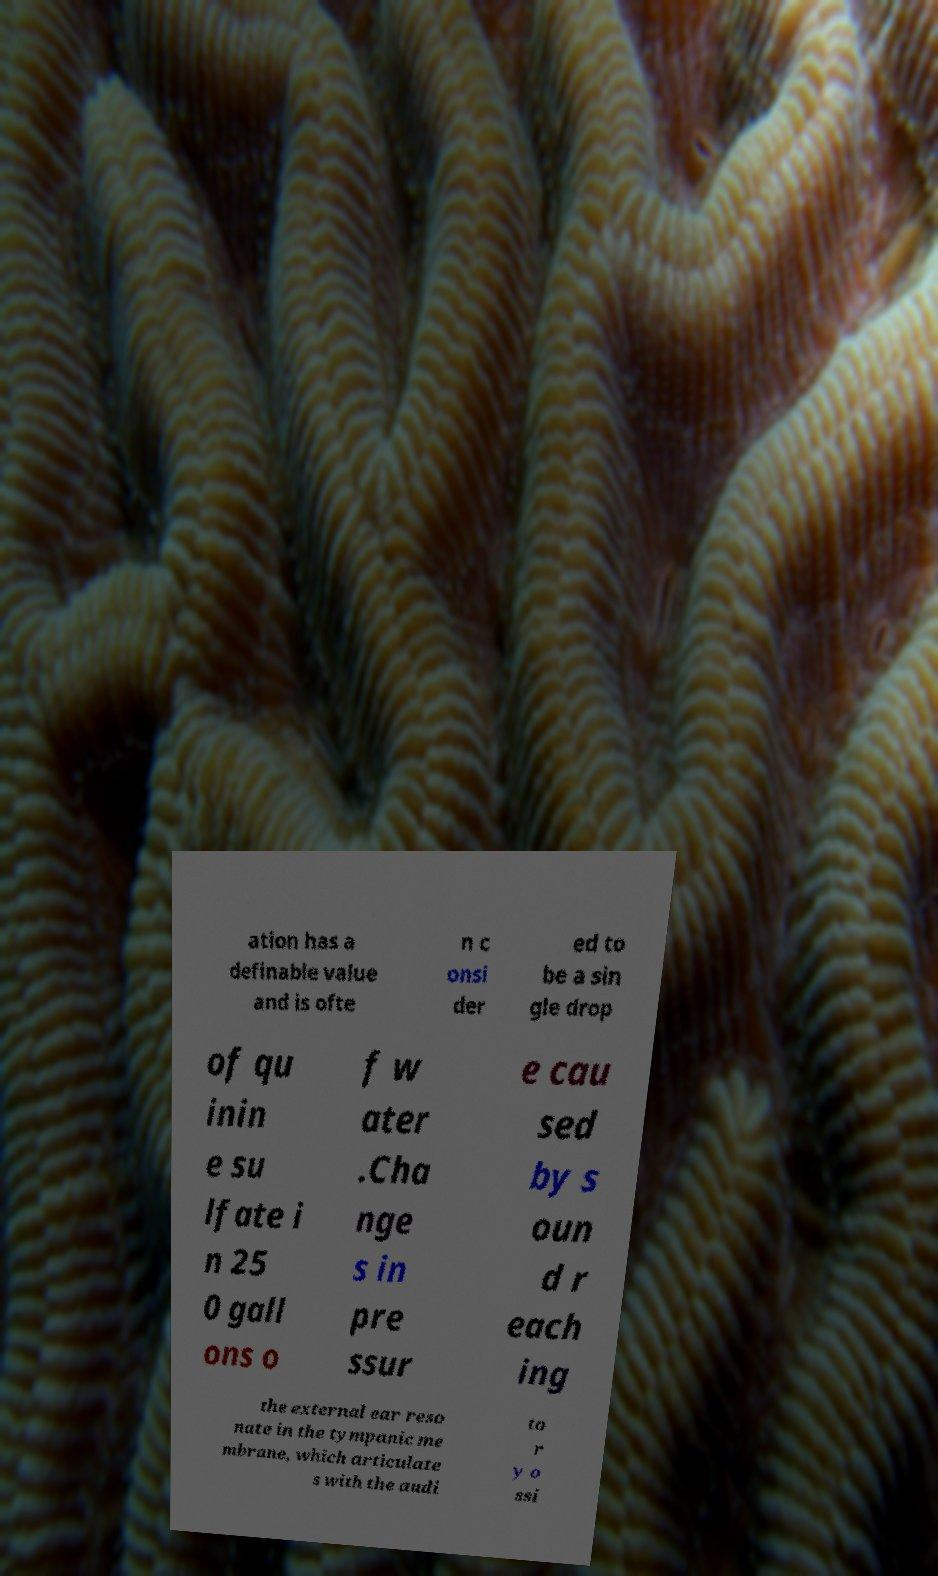For documentation purposes, I need the text within this image transcribed. Could you provide that? ation has a definable value and is ofte n c onsi der ed to be a sin gle drop of qu inin e su lfate i n 25 0 gall ons o f w ater .Cha nge s in pre ssur e cau sed by s oun d r each ing the external ear reso nate in the tympanic me mbrane, which articulate s with the audi to r y o ssi 